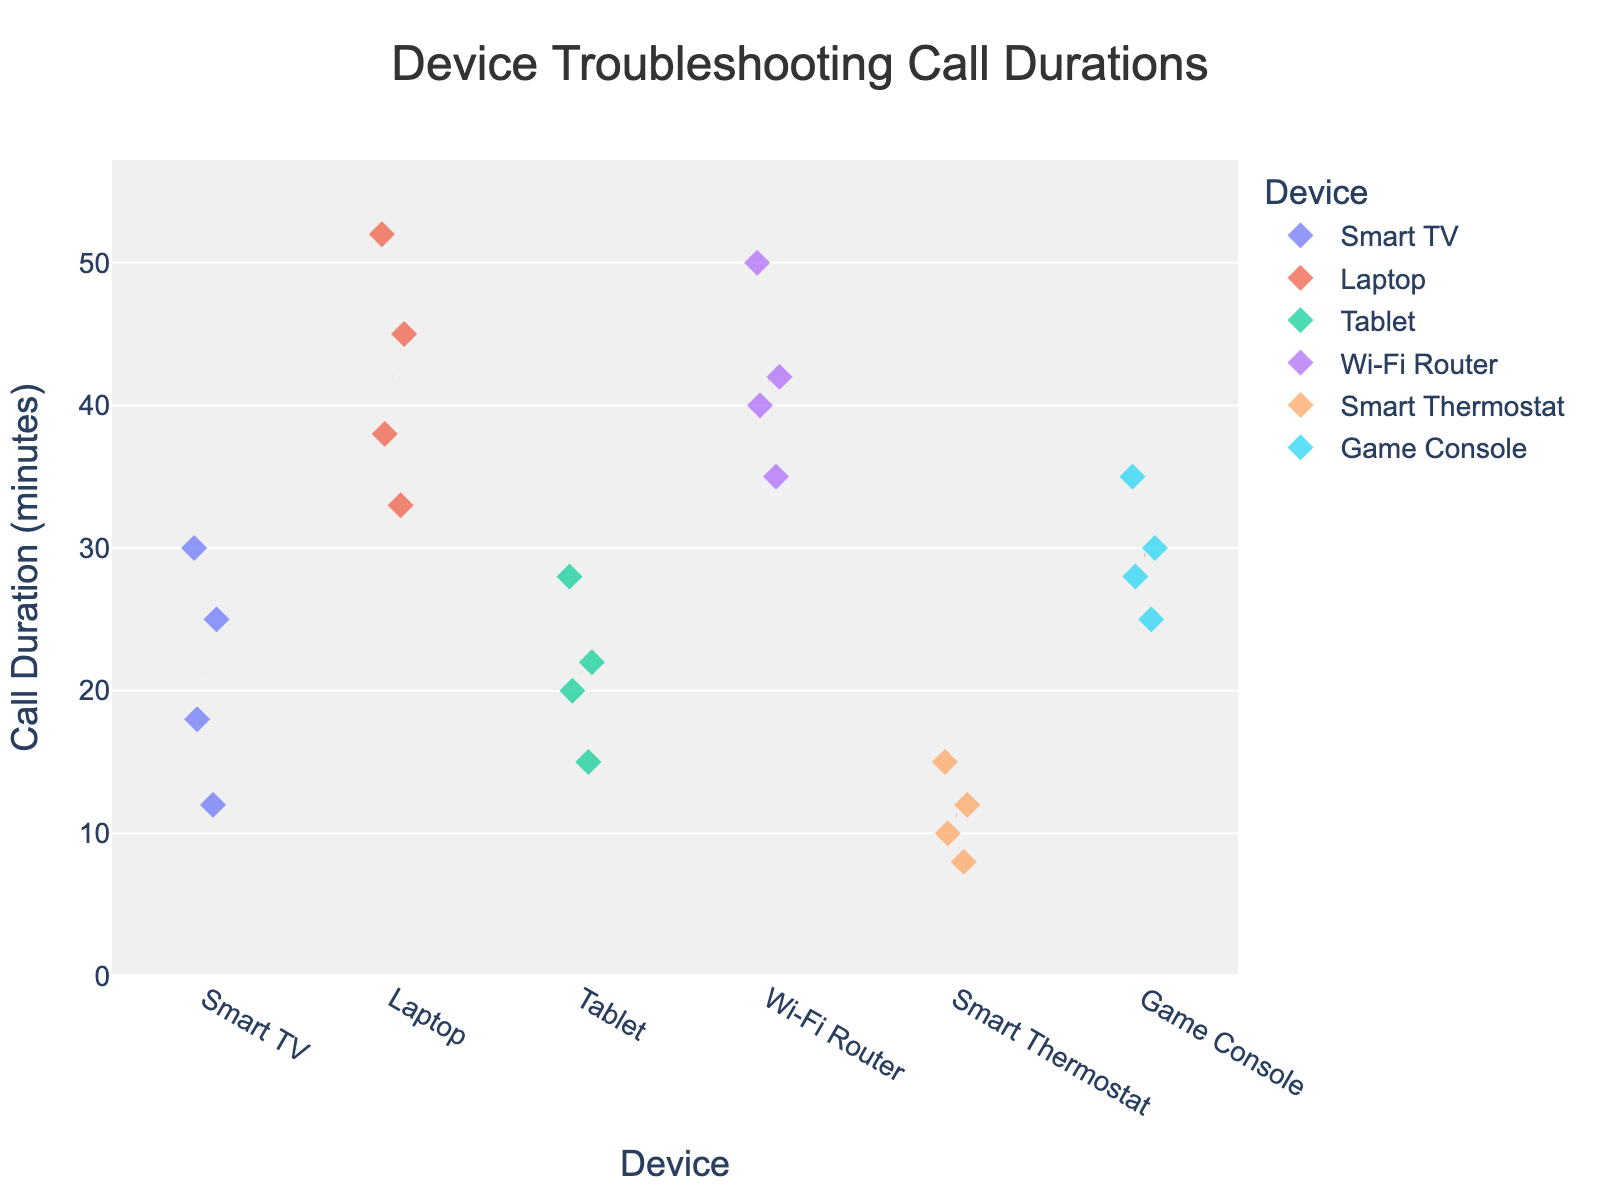What is the title of the plot? The title is displayed at the top center of the plot and usually summarizes what the plot is about.
Answer: Device Troubleshooting Call Durations What is the range of call durations for Smart TVs? The call durations for Smart TVs are displayed as diamond markers in the chart, where the minimum duration is 12 minutes, and the maximum is 30 minutes.
Answer: 12 to 30 minutes Which device has the highest average call duration? To determine the highest average call duration, we reference the red dashed lines representing the mean duration for each device. The device with the highest mean line represents the highest average call duration, which appears to be the Laptop.
Answer: Laptop Compare the call durations for Smart Thermostats and Game Consoles. Which device has a longer maximum call duration? The maximum call duration for each device can be observed by the uppermost diamond marker in the corresponding device category. For Smart Thermostats, the maximum is 15 minutes, while for Game Consoles, it is 35 minutes. Therefore, Game Consoles have a longer maximum call duration.
Answer: Game Consoles What is the shortest call duration recorded for any device, and which device does it belong to? The shortest call duration is represented by the lowest diamond marker on the y-axis. This appears at 8 minutes under the Smart Thermostat category.
Answer: 8 minutes, Smart Thermostat How does the variability of call durations differ between Wi-Fi Routers and Tablets? To compare variability, we look at the spread of diamond markers along the y-axis for each device category. Wi-Fi Routers' call durations range from 35 to 50 minutes, whereas Tablets range from 15 to 28 minutes. Wi-Fi Routers have a larger spread, indicating greater variability.
Answer: Wi-Fi Routers have greater variability In which device category do we find the most consistent (least variable) call durations? The most consistent call durations can be identified by observing the device with the smallest range between its minimum and maximum call duration markers. Smart Thermostats have a narrow range from 8 to 15 minutes.
Answer: Smart Thermostat What is the midpoint of the call duration range for Game Consoles? The midpoint can be calculated by finding the average of the minimum (25 minutes) and maximum (35 minutes) call durations for Game Consoles. (25 + 35) / 2 = 30 minutes.
Answer: 30 minutes Which device categories have at least one call duration above 40 minutes? To identify these categories, we look for any diamond markers above the 40-minute mark on the y-axis. Laptops and Wi-Fi Routers both have call durations exceeding 40 minutes.
Answer: Laptops, Wi-Fi Routers 